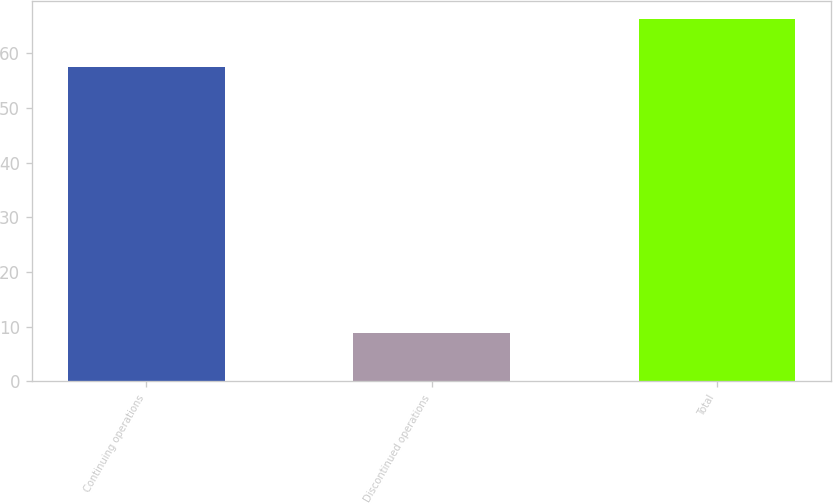<chart> <loc_0><loc_0><loc_500><loc_500><bar_chart><fcel>Continuing operations<fcel>Discontinued operations<fcel>Total<nl><fcel>57.5<fcel>8.8<fcel>66.3<nl></chart> 